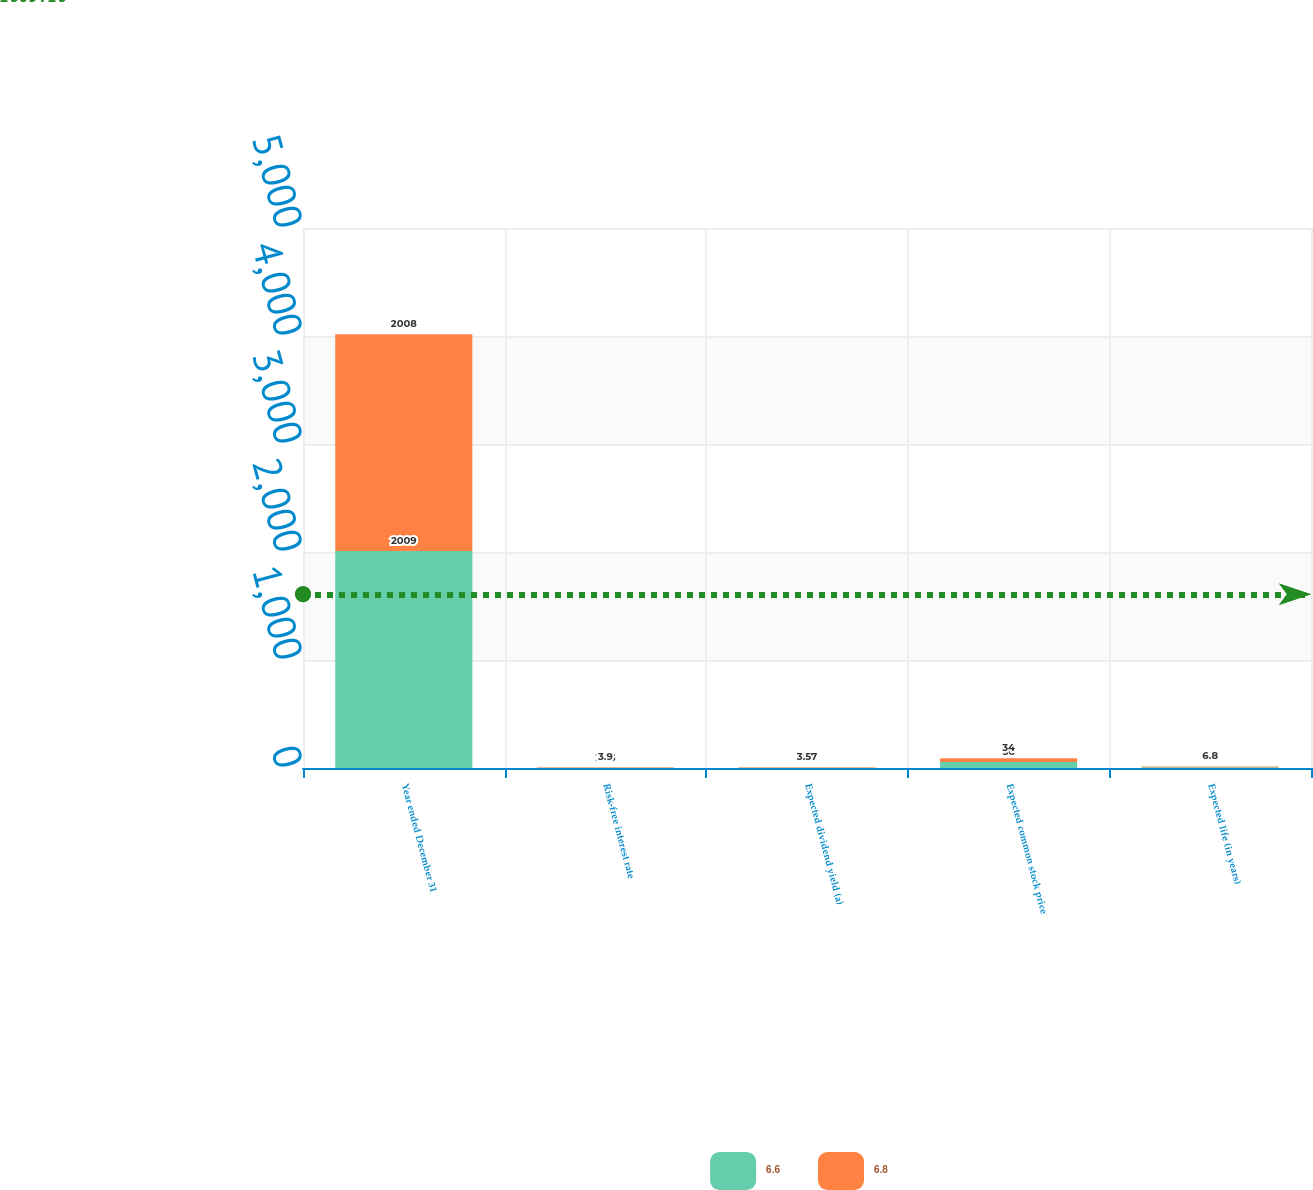<chart> <loc_0><loc_0><loc_500><loc_500><stacked_bar_chart><ecel><fcel>Year ended December 31<fcel>Risk-free interest rate<fcel>Expected dividend yield (a)<fcel>Expected common stock price<fcel>Expected life (in years)<nl><fcel>6.6<fcel>2009<fcel>2.33<fcel>3.4<fcel>56<fcel>6.6<nl><fcel>6.8<fcel>2008<fcel>3.9<fcel>3.57<fcel>34<fcel>6.8<nl></chart> 